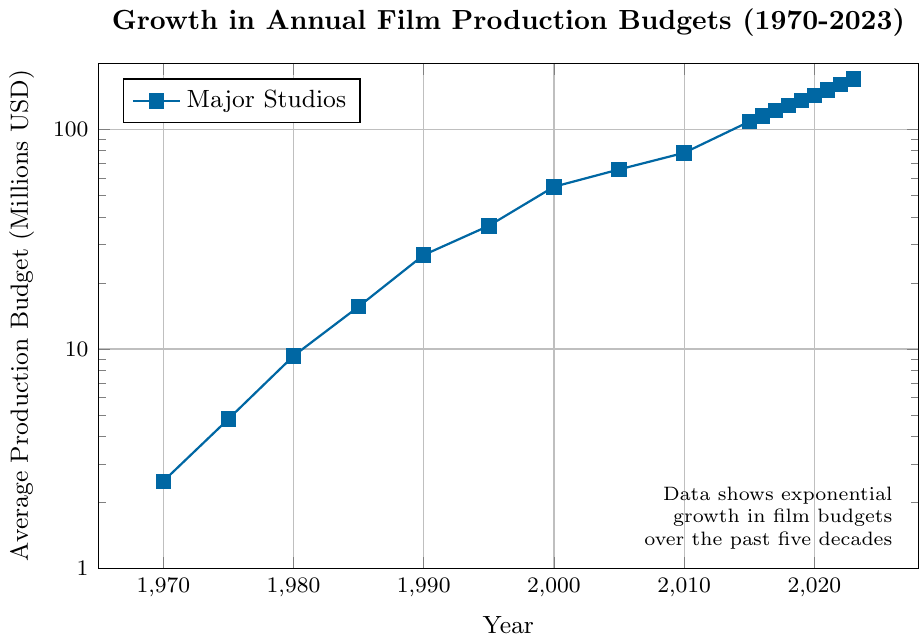what year did the average production budget first exceed 100 million USD? To find the year when the average production budget first exceeded 100 million USD, look for the first data point with a value greater than 100 on the y-axis. From the data points, this occurs in 2015.
Answer: 2015 Which year saw the biggest jump in production budget compared to the previous year? To find the year with the biggest jump, calculate the differences between each consecutive data point and identify the largest. The largest increase is from 2010 (78.2) to 2015 (108.5), a jump of 30.3 million USD.
Answer: 2015 What is the general trend of the average production budget from 1970 to 2023? The plot on log-scale shows a consistent upward trend, indicating exponential growth in the average production budget over the period.
Answer: Exponential growth Is the rate of growth steady or does it show some variability over the years? Analyze the distances between consecutive points on the log-scale. While the growth trend is generally upward, there are periods of higher increases (e.g., from 2010 to 2015) and periods of slower growth (e.g., from 2015 to 2016).
Answer: Shows variability What's the percentage increase in the average production budget from 1970 (2.5 million USD) to 2023 (169.8 million USD)? The percentage increase is calculated using the formula ((new value - old value) / old value) * 100. Using the values 2.5 and 169.8, the calculation is ((169.8 - 2.5) / 2.5) * 100 = 6692%.
Answer: 6692% How does the production budget in 1980 compare to that in 1970? The value in 1980 (9.3 million USD) can be compared to that in 1970 (2.5 million USD) by simply noting that 9.3 is greater than 2.5. Divide 9.3 by 2.5 to find the multiplicative increase: 9.3 / 2.5 = 3.72. The production budget in 1980 is 3.72 times higher than in 1970.
Answer: 3.72 times higher Which period had the most significant increase in average production budget, from 2000 to 2005 or from 2015 to 2020? Calculate the increase in both periods. From 2000 (54.8) to 2005 (65.7) is an increase of 10.9 million USD. From 2015 (108.5) to 2020 (142.9) is an increase of 34.4 million USD. Therefore, 2015 to 2020 had the most significant increase.
Answer: 2015 to 2020 What visual clues suggest that the average production budget has been increasing exponentially? The y-axis is on a logarithmic scale, and the data points form a roughly straight line upwards. Since a straight line on a log-scale indicates exponential growth, this visual clue suggests exponential growth in production budgets.
Answer: Log-scale straight line 